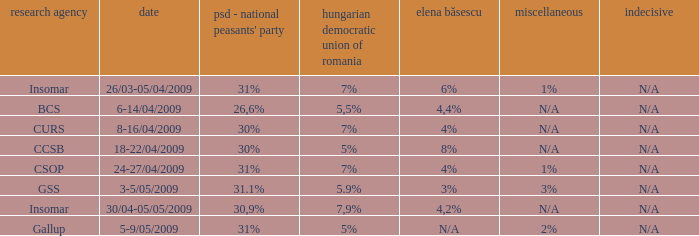What is the elena basescu when the poling firm of gallup? N/A. 